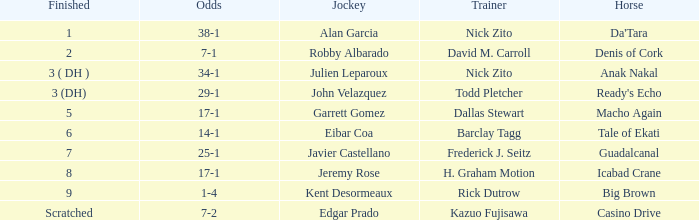What is the Finished place for da'tara trained by Nick zito? 1.0. 